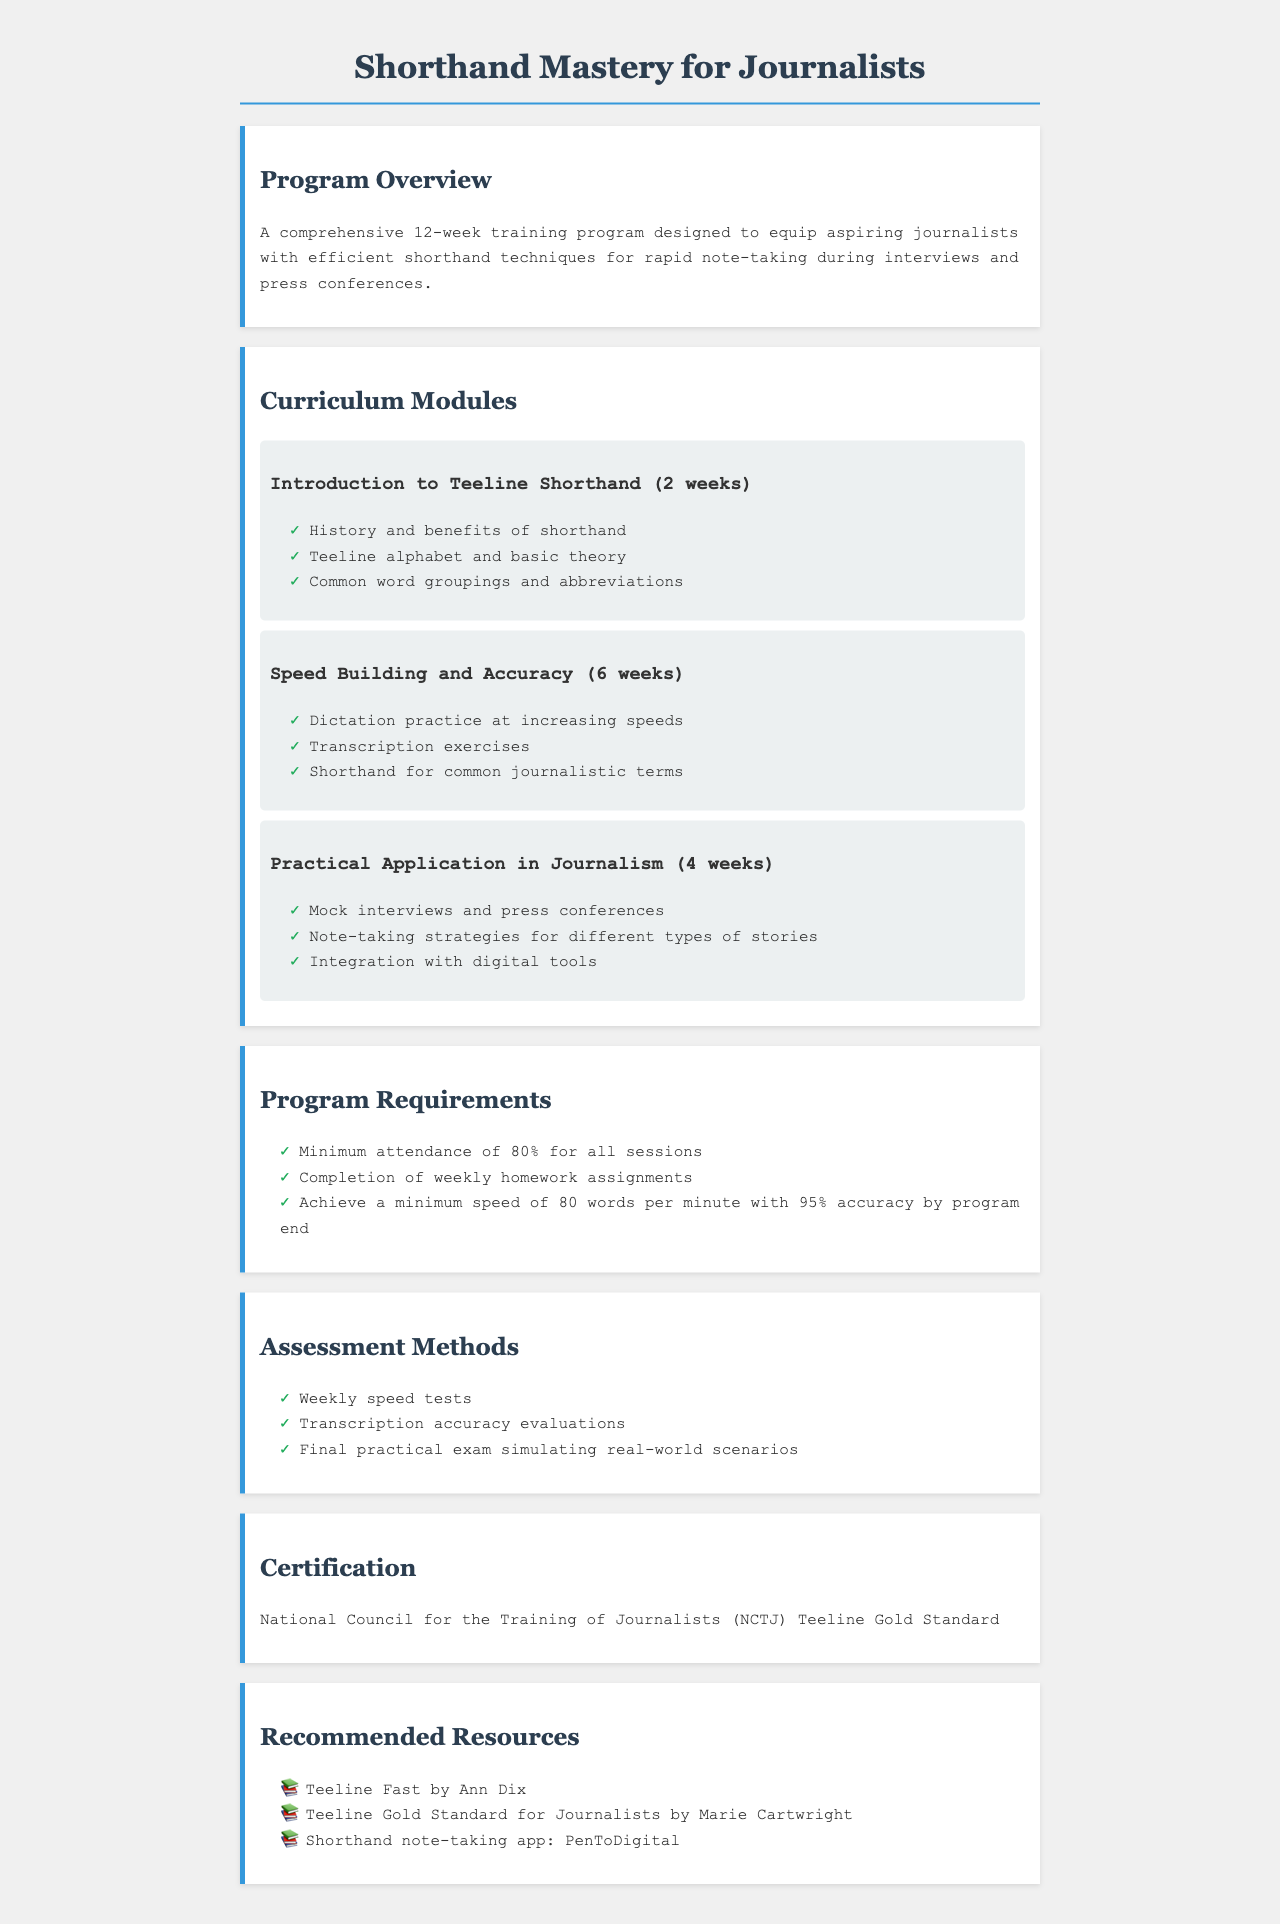What is the duration of the training program? The document states that it is a 12-week training program designed for shorthand mastery.
Answer: 12 weeks What is the first module of the curriculum? The first module covers the 'Introduction to Teeline Shorthand' for 2 weeks, as detailed in the document.
Answer: Introduction to Teeline Shorthand What is the minimum speed required to complete the program? The program requires participants to achieve a minimum speed of 80 words per minute by the end of the program.
Answer: 80 words per minute How many weeks is dedicated to Speed Building and Accuracy? The document specifies that 6 weeks are dedicated to Speed Building and Accuracy in the curriculum modules.
Answer: 6 weeks What certification is awarded upon completion of the program? The completion of the program awards the National Council for the Training of Journalists (NCTJ) Teeline Gold Standard certificate.
Answer: NCTJ Teeline Gold Standard What is the requirement for attendance in the program? Participants must maintain a minimum attendance of 80% for all sessions as stated in the requirements section.
Answer: 80% What type of practice is included in the Practical Application module? The Practical Application module includes mock interviews and press conferences as part of the training.
Answer: Mock interviews and press conferences How many assessment methods are listed in the document? The document lists three assessment methods that will be utilized during the program.
Answer: Three What is the recommended resource related to shorthand note-taking apps? The document recommends the shorthand note-taking app called PenToDigital for students.
Answer: PenToDigital 